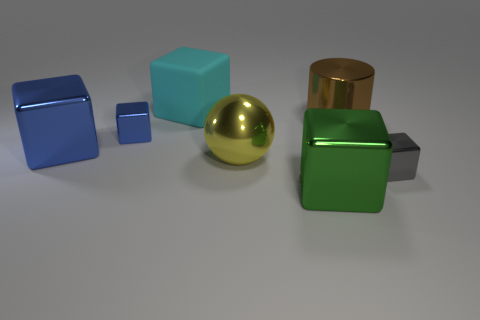Does the big sphere have the same material as the block that is behind the brown shiny cylinder?
Provide a short and direct response. No. There is a cyan thing that is the same size as the green shiny cube; what is its material?
Your answer should be very brief. Rubber. Are there any green cubes that have the same material as the small gray object?
Offer a terse response. Yes. Is there a large thing that is in front of the tiny block right of the big block to the right of the cyan rubber cube?
Ensure brevity in your answer.  Yes. There is a matte thing that is the same size as the metallic sphere; what is its shape?
Offer a very short reply. Cube. There is a metallic block that is in front of the small gray thing; is its size the same as the brown shiny object that is behind the large blue metal object?
Offer a terse response. Yes. What number of small metallic objects are there?
Provide a succinct answer. 2. What is the size of the block on the left side of the blue metallic block that is behind the big metal block that is on the left side of the large cyan rubber object?
Provide a succinct answer. Large. Is there anything else that has the same size as the yellow metallic sphere?
Provide a succinct answer. Yes. There is a rubber cube; what number of yellow shiny balls are to the right of it?
Provide a succinct answer. 1. 